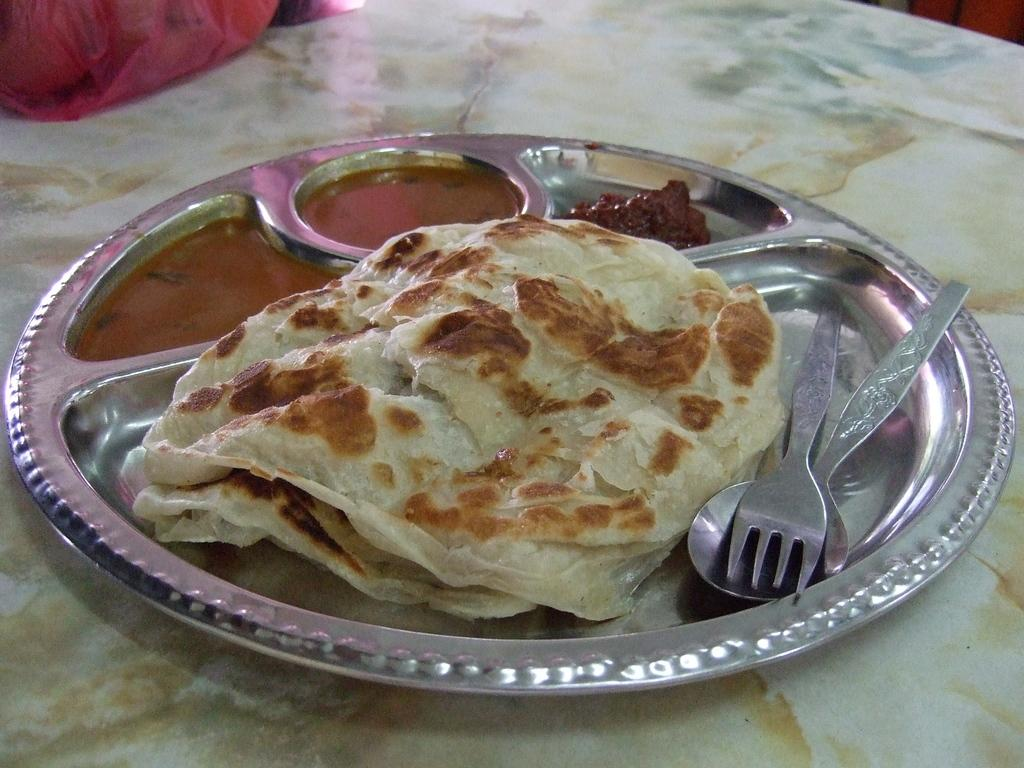What type of objects can be seen in the image? There are food items, a fork, and a spoon in the image. How are the fork and spoon arranged in the image? The fork and spoon are placed on a steel plate in the image. Where is the steel plate located in the image? The steel plate is placed on a surface in the image. What type of book is being read by the family member in the image? There is no family member or book present in the image; it only features food items, a fork, a spoon, and a steel plate. Can you describe the cub that is playing with the food in the image? There is no cub present in the image; it only features food items, a fork, a spoon, and a steel plate. 